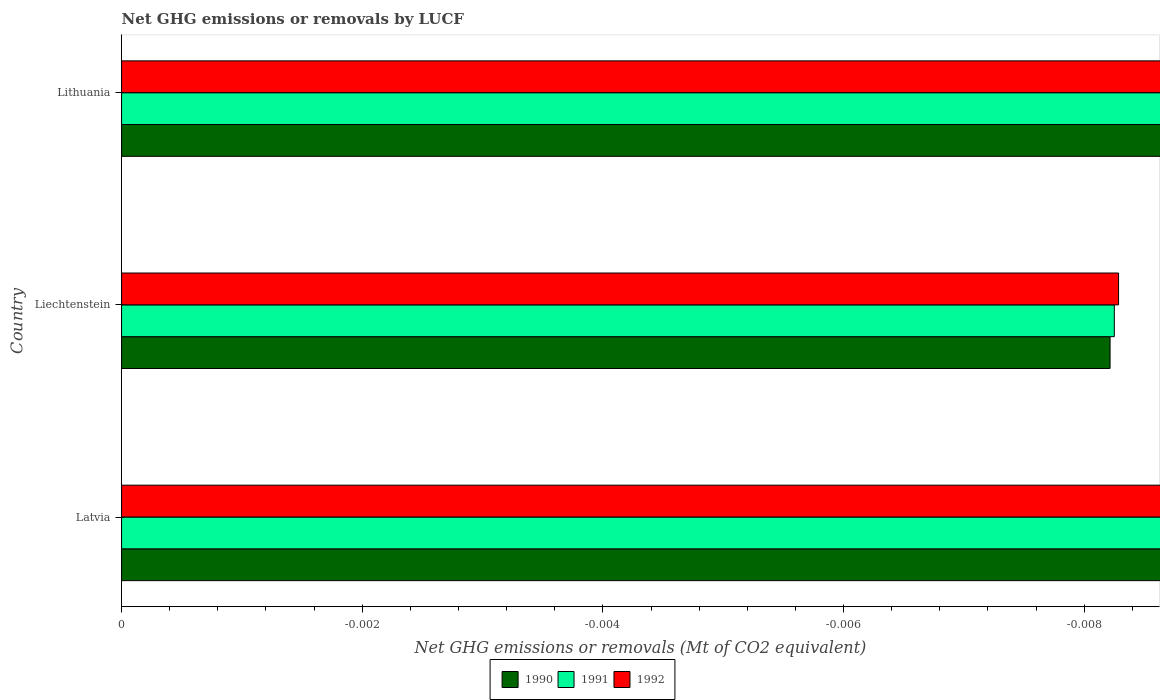Are the number of bars on each tick of the Y-axis equal?
Offer a very short reply. Yes. What is the label of the 2nd group of bars from the top?
Provide a succinct answer. Liechtenstein. What is the difference between the net GHG emissions or removals by LUCF in 1990 in Lithuania and the net GHG emissions or removals by LUCF in 1992 in Latvia?
Provide a succinct answer. 0. What is the average net GHG emissions or removals by LUCF in 1990 per country?
Offer a terse response. 0. In how many countries, is the net GHG emissions or removals by LUCF in 1990 greater than the average net GHG emissions or removals by LUCF in 1990 taken over all countries?
Make the answer very short. 0. Is it the case that in every country, the sum of the net GHG emissions or removals by LUCF in 1991 and net GHG emissions or removals by LUCF in 1990 is greater than the net GHG emissions or removals by LUCF in 1992?
Offer a terse response. No. How many bars are there?
Make the answer very short. 0. How many countries are there in the graph?
Provide a succinct answer. 3. What is the difference between two consecutive major ticks on the X-axis?
Ensure brevity in your answer.  0. Are the values on the major ticks of X-axis written in scientific E-notation?
Offer a very short reply. No. Does the graph contain any zero values?
Ensure brevity in your answer.  Yes. Where does the legend appear in the graph?
Offer a very short reply. Bottom center. How many legend labels are there?
Give a very brief answer. 3. How are the legend labels stacked?
Your answer should be very brief. Horizontal. What is the title of the graph?
Your answer should be compact. Net GHG emissions or removals by LUCF. What is the label or title of the X-axis?
Make the answer very short. Net GHG emissions or removals (Mt of CO2 equivalent). What is the label or title of the Y-axis?
Provide a succinct answer. Country. What is the Net GHG emissions or removals (Mt of CO2 equivalent) of 1990 in Latvia?
Make the answer very short. 0. What is the Net GHG emissions or removals (Mt of CO2 equivalent) of 1991 in Liechtenstein?
Your response must be concise. 0. What is the Net GHG emissions or removals (Mt of CO2 equivalent) in 1992 in Liechtenstein?
Provide a succinct answer. 0. What is the Net GHG emissions or removals (Mt of CO2 equivalent) of 1991 in Lithuania?
Provide a short and direct response. 0. What is the Net GHG emissions or removals (Mt of CO2 equivalent) in 1992 in Lithuania?
Your response must be concise. 0. What is the total Net GHG emissions or removals (Mt of CO2 equivalent) in 1991 in the graph?
Your response must be concise. 0. What is the total Net GHG emissions or removals (Mt of CO2 equivalent) of 1992 in the graph?
Offer a terse response. 0. What is the average Net GHG emissions or removals (Mt of CO2 equivalent) in 1990 per country?
Provide a succinct answer. 0. What is the average Net GHG emissions or removals (Mt of CO2 equivalent) in 1991 per country?
Provide a short and direct response. 0. What is the average Net GHG emissions or removals (Mt of CO2 equivalent) of 1992 per country?
Provide a short and direct response. 0. 